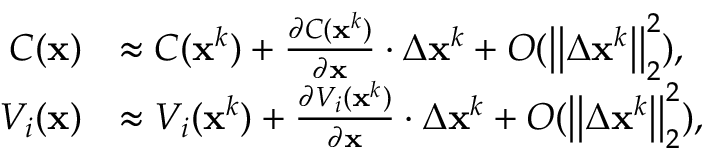Convert formula to latex. <formula><loc_0><loc_0><loc_500><loc_500>\begin{array} { r l } { C ( x ) } & { \approx C ( x ^ { k } ) + \frac { \partial C ( x ^ { k } ) } { \partial x } \cdot \Delta x ^ { k } + O ( \left | \right | \Delta x ^ { k } \left | \right | _ { 2 } ^ { 2 } ) , } \\ { V _ { i } ( x ) } & { \approx V _ { i } ( x ^ { k } ) + \frac { \partial V _ { i } ( x ^ { k } ) } { \partial x } \cdot \Delta x ^ { k } + O ( \left | \right | \Delta x ^ { k } \left | \right | _ { 2 } ^ { 2 } ) , } \end{array}</formula> 